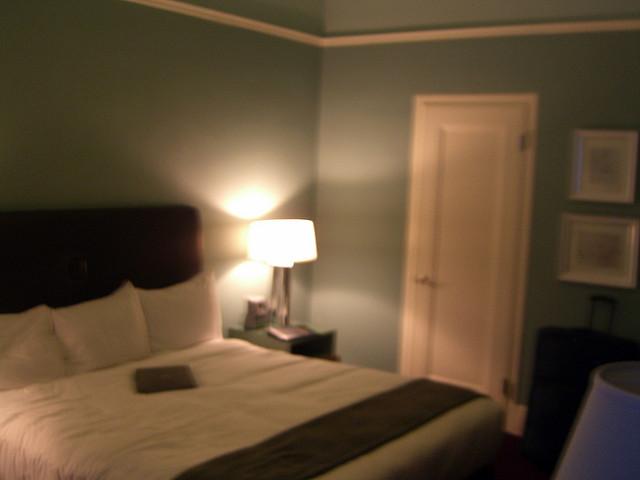How many pillows are there?
Give a very brief answer. 3. How many pillows are on the bed?
Give a very brief answer. 3. How many beds are in this room?
Short answer required. 1. Is the door in this room open?
Short answer required. No. How many panels are in the door?
Quick response, please. 1. How many lights are on?
Answer briefly. 1. Is this bed made?
Concise answer only. Yes. Is the light on?
Give a very brief answer. Yes. How many pictures are on the wall?
Quick response, please. 2. How many lamps are on?
Short answer required. 1. What is in the framed photo on right wall?
Answer briefly. Flowers. Is there a light on in the photo?
Give a very brief answer. Yes. Is the lamp on or off?
Be succinct. On. Could you see the TV by laying in bed?
Concise answer only. Yes. How many lamps are in the picture?
Answer briefly. 1. What color is the wall?
Concise answer only. Green. Does the bed appear to be twin size?
Be succinct. No. Are the lights on?
Give a very brief answer. Yes. Where is the blanket?
Keep it brief. Bed. 